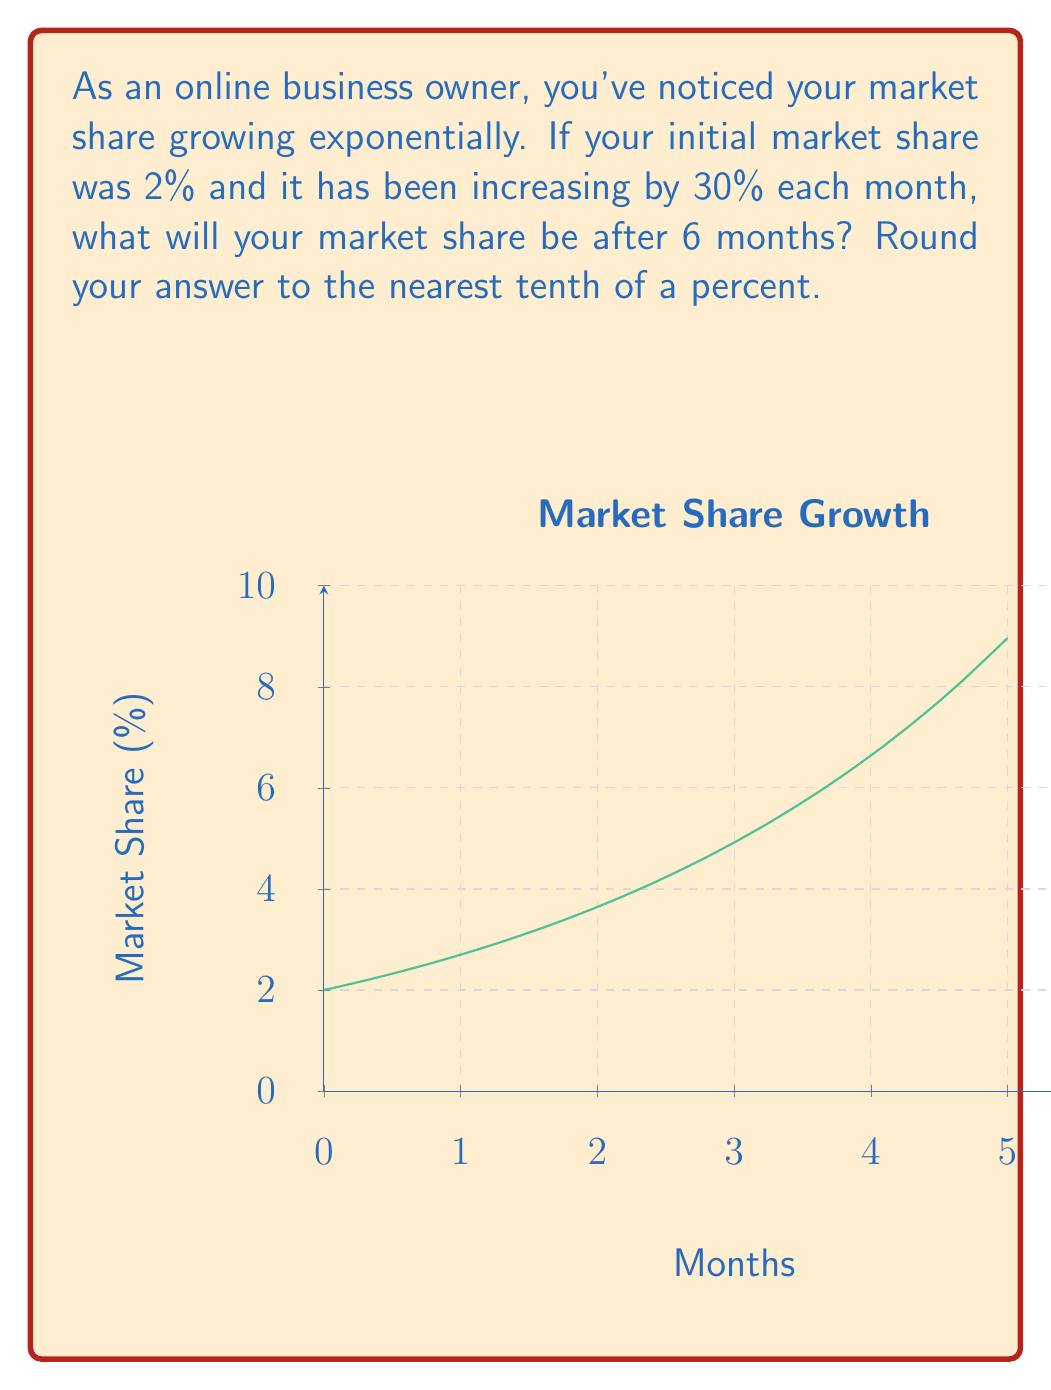Solve this math problem. Let's approach this step-by-step:

1) We can model this situation using an exponential function:

   $P(t) = P_0 \cdot (1 + r)^t$

   Where:
   $P(t)$ is the market share after time $t$
   $P_0$ is the initial market share
   $r$ is the growth rate
   $t$ is the time in months

2) We know:
   $P_0 = 2\%$ (initial market share)
   $r = 30\% = 0.3$ (monthly growth rate)
   $t = 6$ months

3) Plugging these values into our equation:

   $P(6) = 2 \cdot (1 + 0.3)^6$

4) Let's calculate:
   $P(6) = 2 \cdot (1.3)^6$
   $P(6) = 2 \cdot 4.826809$
   $P(6) = 9.653618\%$

5) Rounding to the nearest tenth of a percent:
   $P(6) \approx 9.7\%$
Answer: 9.7% 